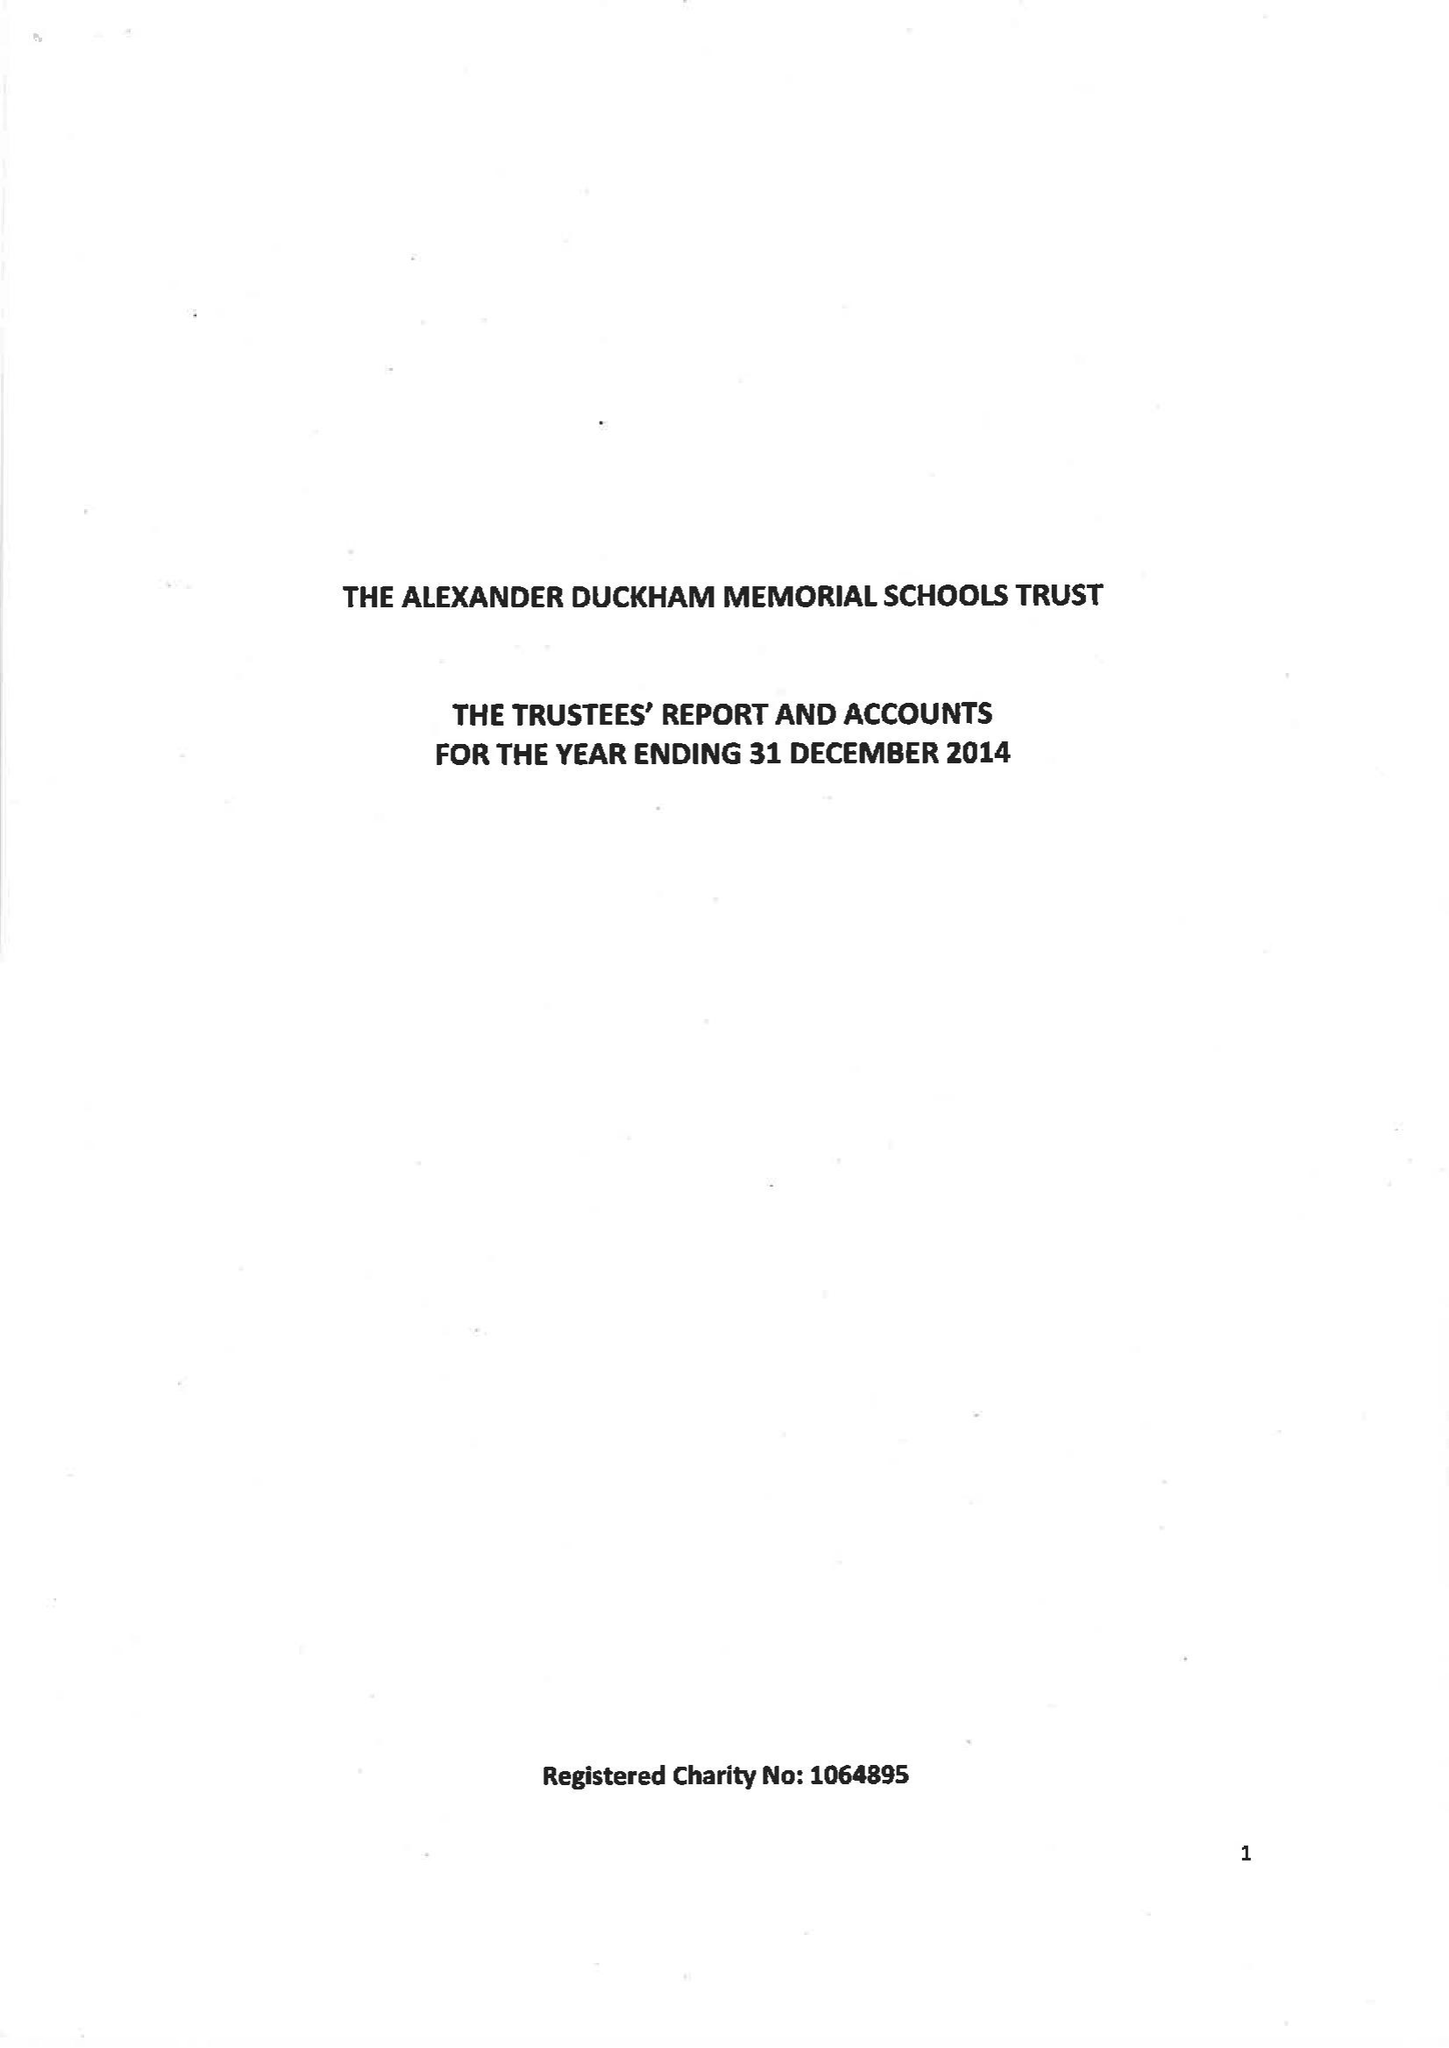What is the value for the charity_name?
Answer the question using a single word or phrase. The Alexander Duckham Memorial Schools Trust 